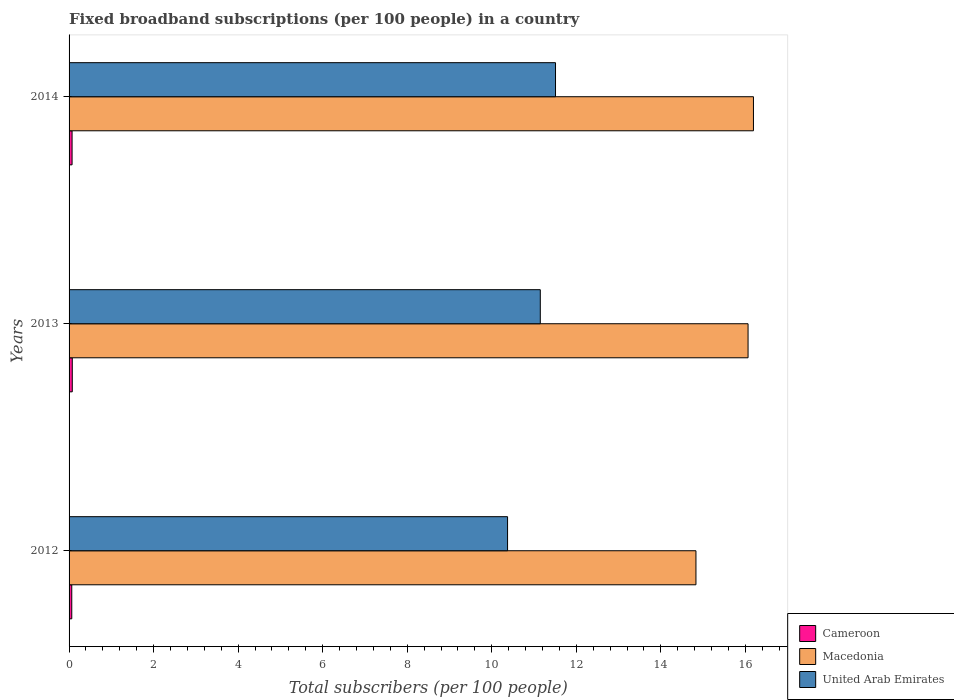How many different coloured bars are there?
Make the answer very short. 3. In how many cases, is the number of bars for a given year not equal to the number of legend labels?
Provide a succinct answer. 0. What is the number of broadband subscriptions in United Arab Emirates in 2014?
Make the answer very short. 11.51. Across all years, what is the maximum number of broadband subscriptions in Cameroon?
Offer a terse response. 0.08. Across all years, what is the minimum number of broadband subscriptions in Cameroon?
Your answer should be very brief. 0.06. What is the total number of broadband subscriptions in Cameroon in the graph?
Keep it short and to the point. 0.21. What is the difference between the number of broadband subscriptions in Cameroon in 2012 and that in 2013?
Offer a terse response. -0.01. What is the difference between the number of broadband subscriptions in United Arab Emirates in 2014 and the number of broadband subscriptions in Cameroon in 2013?
Ensure brevity in your answer.  11.43. What is the average number of broadband subscriptions in Cameroon per year?
Your answer should be very brief. 0.07. In the year 2014, what is the difference between the number of broadband subscriptions in Macedonia and number of broadband subscriptions in Cameroon?
Keep it short and to the point. 16.12. In how many years, is the number of broadband subscriptions in Cameroon greater than 11.2 ?
Ensure brevity in your answer.  0. What is the ratio of the number of broadband subscriptions in Macedonia in 2012 to that in 2014?
Make the answer very short. 0.92. What is the difference between the highest and the second highest number of broadband subscriptions in Cameroon?
Offer a very short reply. 0. What is the difference between the highest and the lowest number of broadband subscriptions in Macedonia?
Make the answer very short. 1.36. What does the 3rd bar from the top in 2012 represents?
Your answer should be compact. Cameroon. What does the 2nd bar from the bottom in 2012 represents?
Offer a terse response. Macedonia. Is it the case that in every year, the sum of the number of broadband subscriptions in Macedonia and number of broadband subscriptions in Cameroon is greater than the number of broadband subscriptions in United Arab Emirates?
Make the answer very short. Yes. How many bars are there?
Give a very brief answer. 9. How many years are there in the graph?
Provide a short and direct response. 3. Are the values on the major ticks of X-axis written in scientific E-notation?
Provide a succinct answer. No. Does the graph contain any zero values?
Give a very brief answer. No. Does the graph contain grids?
Give a very brief answer. No. What is the title of the graph?
Offer a very short reply. Fixed broadband subscriptions (per 100 people) in a country. What is the label or title of the X-axis?
Ensure brevity in your answer.  Total subscribers (per 100 people). What is the label or title of the Y-axis?
Provide a short and direct response. Years. What is the Total subscribers (per 100 people) in Cameroon in 2012?
Ensure brevity in your answer.  0.06. What is the Total subscribers (per 100 people) of Macedonia in 2012?
Offer a very short reply. 14.83. What is the Total subscribers (per 100 people) of United Arab Emirates in 2012?
Ensure brevity in your answer.  10.37. What is the Total subscribers (per 100 people) in Cameroon in 2013?
Make the answer very short. 0.08. What is the Total subscribers (per 100 people) of Macedonia in 2013?
Keep it short and to the point. 16.06. What is the Total subscribers (per 100 people) of United Arab Emirates in 2013?
Give a very brief answer. 11.15. What is the Total subscribers (per 100 people) in Cameroon in 2014?
Keep it short and to the point. 0.07. What is the Total subscribers (per 100 people) in Macedonia in 2014?
Your answer should be compact. 16.19. What is the Total subscribers (per 100 people) in United Arab Emirates in 2014?
Make the answer very short. 11.51. Across all years, what is the maximum Total subscribers (per 100 people) in Cameroon?
Make the answer very short. 0.08. Across all years, what is the maximum Total subscribers (per 100 people) of Macedonia?
Give a very brief answer. 16.19. Across all years, what is the maximum Total subscribers (per 100 people) of United Arab Emirates?
Your answer should be compact. 11.51. Across all years, what is the minimum Total subscribers (per 100 people) in Cameroon?
Give a very brief answer. 0.06. Across all years, what is the minimum Total subscribers (per 100 people) of Macedonia?
Your answer should be compact. 14.83. Across all years, what is the minimum Total subscribers (per 100 people) in United Arab Emirates?
Your response must be concise. 10.37. What is the total Total subscribers (per 100 people) in Cameroon in the graph?
Provide a succinct answer. 0.21. What is the total Total subscribers (per 100 people) of Macedonia in the graph?
Make the answer very short. 47.09. What is the total Total subscribers (per 100 people) of United Arab Emirates in the graph?
Offer a terse response. 33.03. What is the difference between the Total subscribers (per 100 people) in Cameroon in 2012 and that in 2013?
Your answer should be compact. -0.01. What is the difference between the Total subscribers (per 100 people) in Macedonia in 2012 and that in 2013?
Make the answer very short. -1.23. What is the difference between the Total subscribers (per 100 people) of United Arab Emirates in 2012 and that in 2013?
Your answer should be compact. -0.77. What is the difference between the Total subscribers (per 100 people) in Cameroon in 2012 and that in 2014?
Ensure brevity in your answer.  -0.01. What is the difference between the Total subscribers (per 100 people) of Macedonia in 2012 and that in 2014?
Keep it short and to the point. -1.36. What is the difference between the Total subscribers (per 100 people) in United Arab Emirates in 2012 and that in 2014?
Your response must be concise. -1.13. What is the difference between the Total subscribers (per 100 people) of Cameroon in 2013 and that in 2014?
Your answer should be very brief. 0. What is the difference between the Total subscribers (per 100 people) in Macedonia in 2013 and that in 2014?
Ensure brevity in your answer.  -0.13. What is the difference between the Total subscribers (per 100 people) in United Arab Emirates in 2013 and that in 2014?
Your answer should be very brief. -0.36. What is the difference between the Total subscribers (per 100 people) in Cameroon in 2012 and the Total subscribers (per 100 people) in Macedonia in 2013?
Your answer should be compact. -16. What is the difference between the Total subscribers (per 100 people) of Cameroon in 2012 and the Total subscribers (per 100 people) of United Arab Emirates in 2013?
Your answer should be very brief. -11.08. What is the difference between the Total subscribers (per 100 people) of Macedonia in 2012 and the Total subscribers (per 100 people) of United Arab Emirates in 2013?
Your response must be concise. 3.68. What is the difference between the Total subscribers (per 100 people) of Cameroon in 2012 and the Total subscribers (per 100 people) of Macedonia in 2014?
Keep it short and to the point. -16.13. What is the difference between the Total subscribers (per 100 people) in Cameroon in 2012 and the Total subscribers (per 100 people) in United Arab Emirates in 2014?
Your answer should be very brief. -11.44. What is the difference between the Total subscribers (per 100 people) in Macedonia in 2012 and the Total subscribers (per 100 people) in United Arab Emirates in 2014?
Give a very brief answer. 3.32. What is the difference between the Total subscribers (per 100 people) of Cameroon in 2013 and the Total subscribers (per 100 people) of Macedonia in 2014?
Keep it short and to the point. -16.11. What is the difference between the Total subscribers (per 100 people) in Cameroon in 2013 and the Total subscribers (per 100 people) in United Arab Emirates in 2014?
Provide a succinct answer. -11.43. What is the difference between the Total subscribers (per 100 people) in Macedonia in 2013 and the Total subscribers (per 100 people) in United Arab Emirates in 2014?
Your response must be concise. 4.56. What is the average Total subscribers (per 100 people) in Cameroon per year?
Give a very brief answer. 0.07. What is the average Total subscribers (per 100 people) in Macedonia per year?
Your answer should be compact. 15.7. What is the average Total subscribers (per 100 people) in United Arab Emirates per year?
Your answer should be very brief. 11.01. In the year 2012, what is the difference between the Total subscribers (per 100 people) in Cameroon and Total subscribers (per 100 people) in Macedonia?
Ensure brevity in your answer.  -14.77. In the year 2012, what is the difference between the Total subscribers (per 100 people) in Cameroon and Total subscribers (per 100 people) in United Arab Emirates?
Give a very brief answer. -10.31. In the year 2012, what is the difference between the Total subscribers (per 100 people) in Macedonia and Total subscribers (per 100 people) in United Arab Emirates?
Provide a succinct answer. 4.46. In the year 2013, what is the difference between the Total subscribers (per 100 people) of Cameroon and Total subscribers (per 100 people) of Macedonia?
Provide a succinct answer. -15.99. In the year 2013, what is the difference between the Total subscribers (per 100 people) of Cameroon and Total subscribers (per 100 people) of United Arab Emirates?
Your answer should be compact. -11.07. In the year 2013, what is the difference between the Total subscribers (per 100 people) of Macedonia and Total subscribers (per 100 people) of United Arab Emirates?
Keep it short and to the point. 4.92. In the year 2014, what is the difference between the Total subscribers (per 100 people) of Cameroon and Total subscribers (per 100 people) of Macedonia?
Give a very brief answer. -16.12. In the year 2014, what is the difference between the Total subscribers (per 100 people) of Cameroon and Total subscribers (per 100 people) of United Arab Emirates?
Your answer should be compact. -11.44. In the year 2014, what is the difference between the Total subscribers (per 100 people) of Macedonia and Total subscribers (per 100 people) of United Arab Emirates?
Your answer should be compact. 4.68. What is the ratio of the Total subscribers (per 100 people) of Cameroon in 2012 to that in 2013?
Ensure brevity in your answer.  0.84. What is the ratio of the Total subscribers (per 100 people) in Macedonia in 2012 to that in 2013?
Your answer should be compact. 0.92. What is the ratio of the Total subscribers (per 100 people) of United Arab Emirates in 2012 to that in 2013?
Give a very brief answer. 0.93. What is the ratio of the Total subscribers (per 100 people) in Cameroon in 2012 to that in 2014?
Your response must be concise. 0.9. What is the ratio of the Total subscribers (per 100 people) of Macedonia in 2012 to that in 2014?
Your answer should be very brief. 0.92. What is the ratio of the Total subscribers (per 100 people) of United Arab Emirates in 2012 to that in 2014?
Your answer should be very brief. 0.9. What is the ratio of the Total subscribers (per 100 people) in Cameroon in 2013 to that in 2014?
Give a very brief answer. 1.07. What is the ratio of the Total subscribers (per 100 people) in Macedonia in 2013 to that in 2014?
Make the answer very short. 0.99. What is the ratio of the Total subscribers (per 100 people) of United Arab Emirates in 2013 to that in 2014?
Your answer should be compact. 0.97. What is the difference between the highest and the second highest Total subscribers (per 100 people) of Cameroon?
Offer a very short reply. 0. What is the difference between the highest and the second highest Total subscribers (per 100 people) of Macedonia?
Provide a short and direct response. 0.13. What is the difference between the highest and the second highest Total subscribers (per 100 people) in United Arab Emirates?
Provide a short and direct response. 0.36. What is the difference between the highest and the lowest Total subscribers (per 100 people) of Cameroon?
Your response must be concise. 0.01. What is the difference between the highest and the lowest Total subscribers (per 100 people) of Macedonia?
Make the answer very short. 1.36. What is the difference between the highest and the lowest Total subscribers (per 100 people) of United Arab Emirates?
Your answer should be compact. 1.13. 